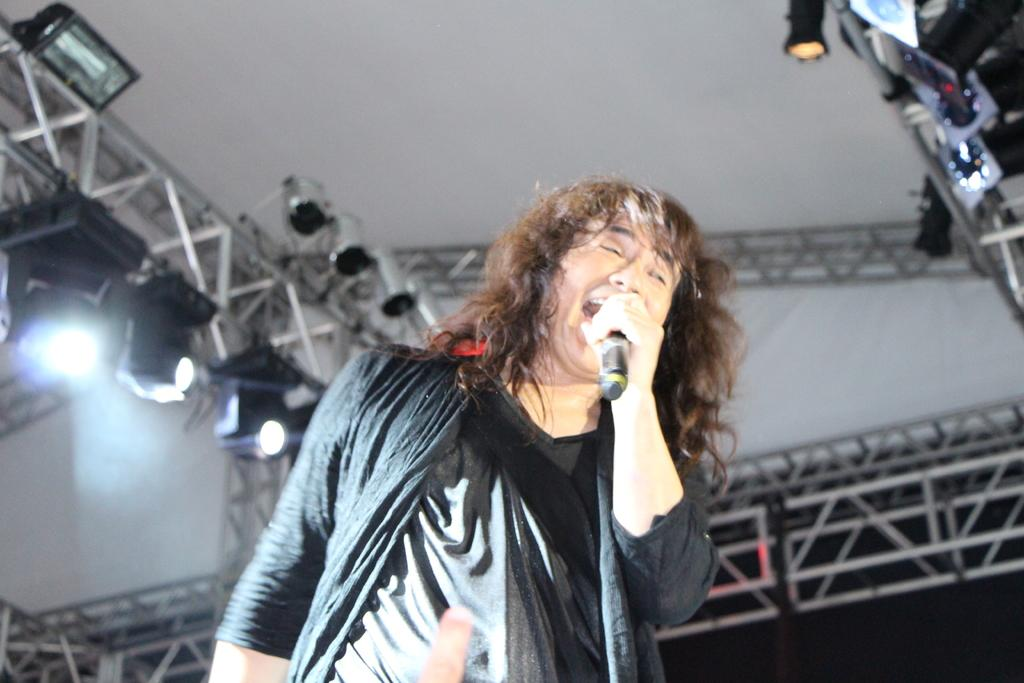What is the main subject of the image? There is a person standing in the front of the image. What is the person doing in the image? The person is singing. What object is the person holding in his hand? The person is holding a microphone in his hand. What can be seen in the background of the image? There are lights and stands in the background of the image. How does the person say good-bye to the audience in the image? There is no indication in the image that the person is saying good-bye to the audience. 